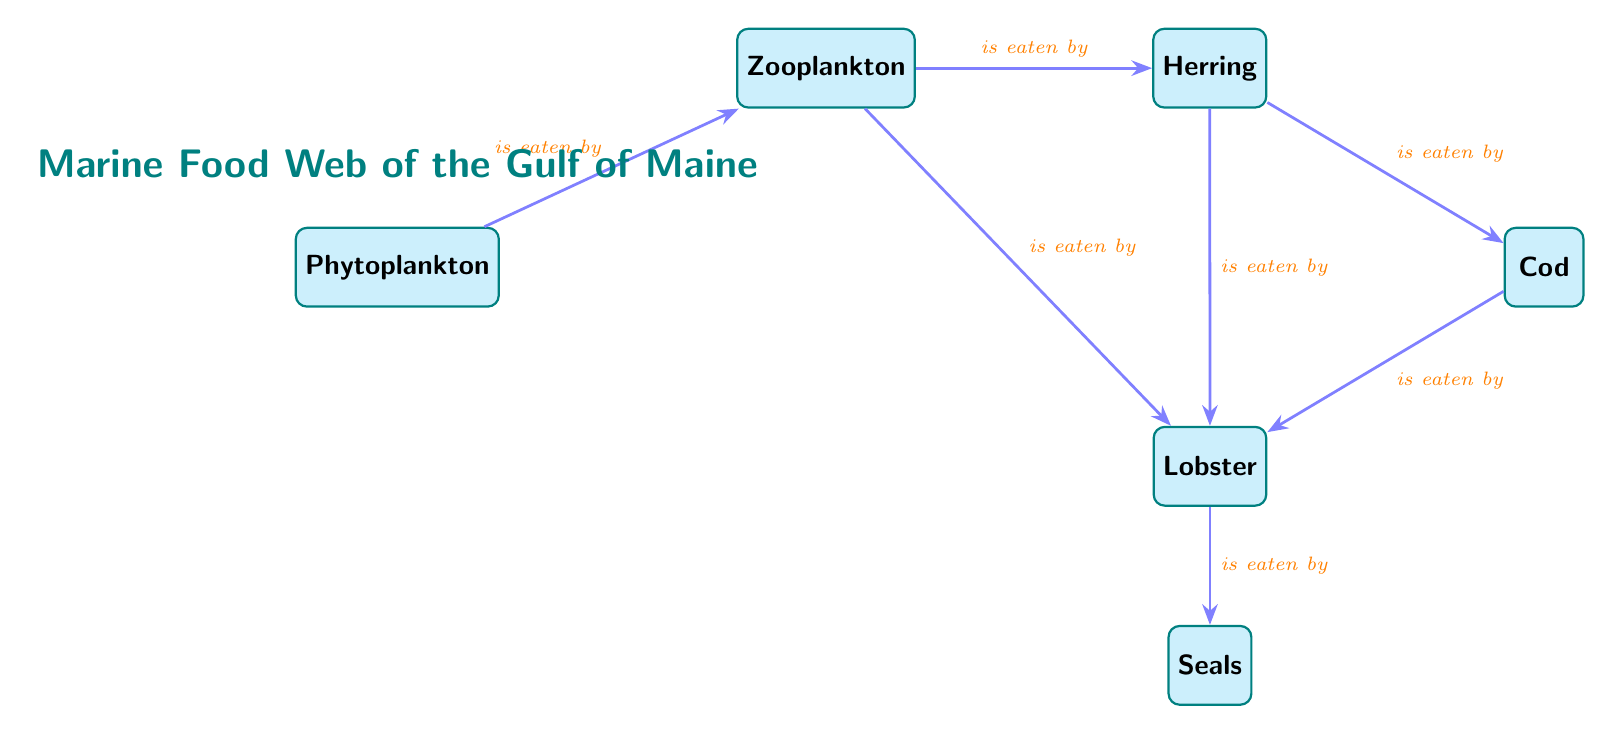What is the top node in the diagram? The top node in the diagram is "Phytoplankton," which is the starting point in the food web as it represents the primary producers.
Answer: Phytoplankton How many nodes are present in the food web? By counting every unique entity in the diagram, we see there are a total of six nodes: Phytoplankton, Zooplankton, Herring, Cod, Lobster, and Seals.
Answer: 6 Which organism is eaten by both herring and lobster? The organism that is consumed by both herring and lobster is "Zooplankton," as indicated by the directed edges leading from it to both of these organisms in the diagram.
Answer: Zooplankton Who is at the end of the food chain? The end of the food chain is represented by "Seals," which are shown as consuming lobsters, indicating that they are the top predators in this marine food web.
Answer: Seals How many direct relationships does the lobster have? The lobster has three direct relationships: it is eaten by seals and eats zooplankton, herring, and cod, totaling three connections in the food web.
Answer: 3 What is the relationship between herring and cod? The relationship between herring and cod is that "Cod" eats "Herring," as seen in the directed edge from herring to cod in the diagram.
Answer: is eaten by Which organism is the primary consumer of phytoplankton? The primary consumer of phytoplankton in the food web is "Zooplankton," which directly consumes phytoplankton as indicated by the edge connecting the two.
Answer: Zooplankton If lobsters were removed from the food web, which organism would be directly affected? If lobsters were removed, "Seals" would be directly affected, as they rely on lobsters as a food source, representing a connection that would be broken.
Answer: Seals What type of relationship connects zooplankton and the cod? The type of relationship connecting zooplankton and the cod is that cod "eats" zooplankton, which establishes a predator-prey dynamic between the two.
Answer: is eaten by How many organisms does herring directly interact with? Herring has two direct interactions: it is eaten by cod, and it eats zooplankton, which means it connects to two other organisms in the web.
Answer: 2 